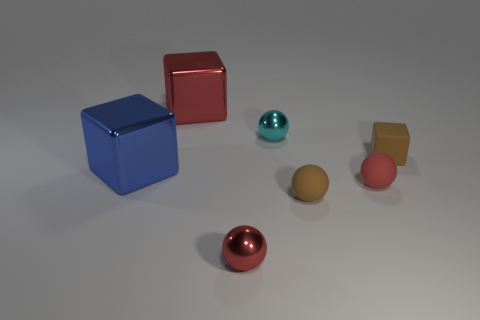What number of other objects are the same color as the small block?
Your answer should be very brief. 1. Is there anything else that is the same size as the cyan ball?
Keep it short and to the point. Yes. How many other objects are the same shape as the tiny red metal object?
Your answer should be very brief. 3. Do the red rubber object and the cyan object have the same size?
Make the answer very short. Yes. Are there any tiny red matte things?
Give a very brief answer. Yes. Is there any other thing that has the same material as the blue object?
Offer a terse response. Yes. Is there another blue block made of the same material as the small block?
Keep it short and to the point. No. There is a cyan sphere that is the same size as the brown matte cube; what is it made of?
Your response must be concise. Metal. What number of other things are the same shape as the small cyan object?
Keep it short and to the point. 3. There is a brown ball that is made of the same material as the small brown block; what is its size?
Provide a short and direct response. Small. 